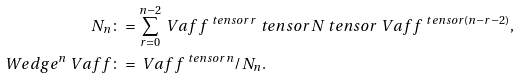<formula> <loc_0><loc_0><loc_500><loc_500>N _ { n } & \colon = \sum _ { r = 0 } ^ { n - 2 } \ V a f f ^ { \ t e n s o r r } \ t e n s o r N \ t e n s o r \ V a f f ^ { \ t e n s o r ( n - r - 2 ) } , \\ \ W e d g e ^ { n } \ V a f f & \colon = \ V a f f ^ { \ t e n s o r n } / N _ { n } .</formula> 